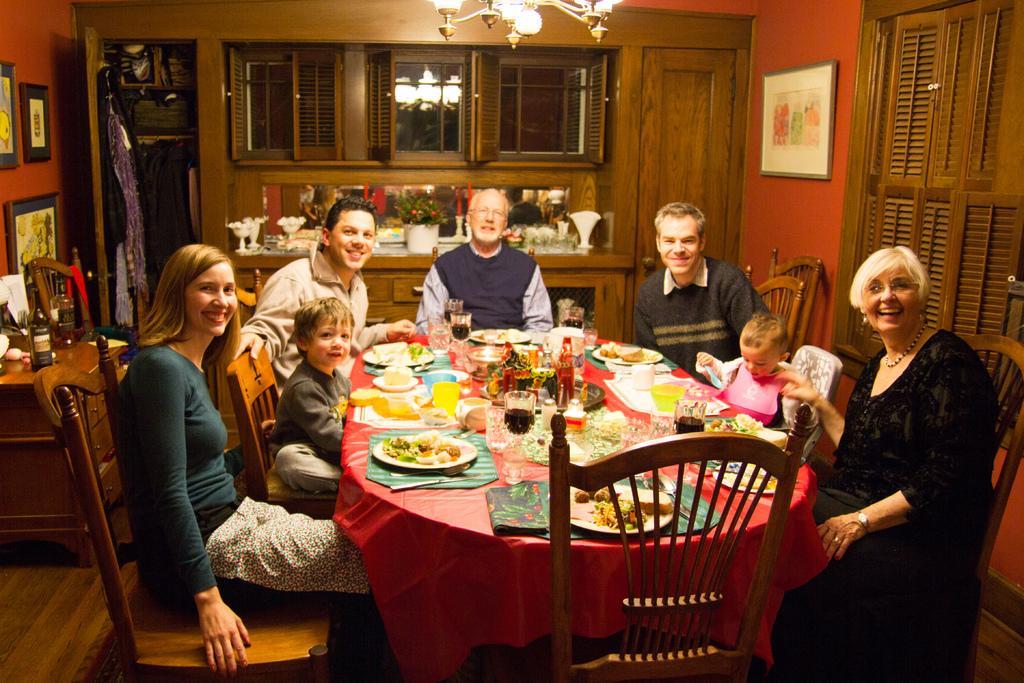Can you describe this image briefly? In the middle there is a table ,on the table there are plates ,cups ,glasses ,bottles and some other food items. Around the table there are 7 people. On the right there is a woman she wear a black dress she is smiling her hair is short. In the middle there is a man he is staring at something. On the left there is a woman she wear a t shirt she is smiling her hair is short. In the back ground there is a window ,light ,glass,photo frame ,bottle ,door and wall. I think this is a house. 